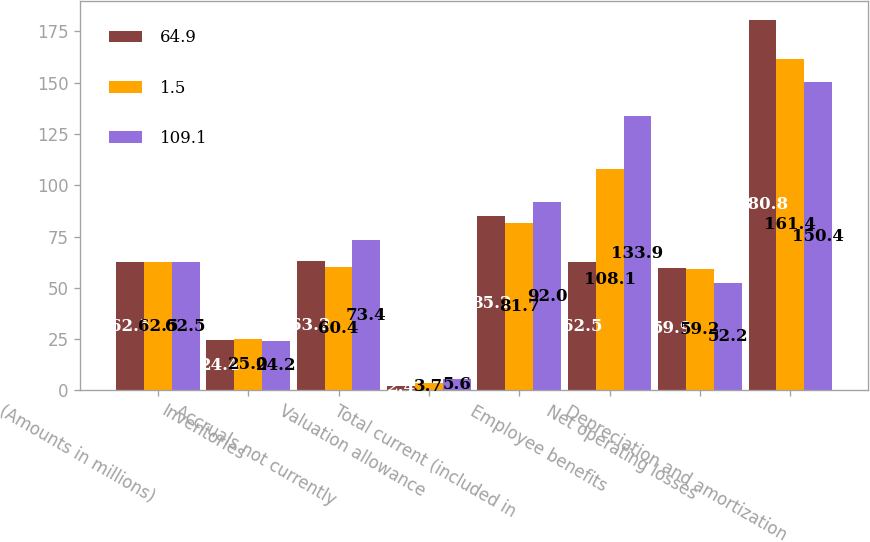Convert chart. <chart><loc_0><loc_0><loc_500><loc_500><stacked_bar_chart><ecel><fcel>(Amounts in millions)<fcel>Inventories<fcel>Accruals not currently<fcel>Valuation allowance<fcel>Total current (included in<fcel>Employee benefits<fcel>Net operating losses<fcel>Depreciation and amortization<nl><fcel>64.9<fcel>62.5<fcel>24.4<fcel>63.2<fcel>2.4<fcel>85.2<fcel>62.5<fcel>59.9<fcel>180.8<nl><fcel>1.5<fcel>62.5<fcel>25<fcel>60.4<fcel>3.7<fcel>81.7<fcel>108.1<fcel>59.2<fcel>161.4<nl><fcel>109.1<fcel>62.5<fcel>24.2<fcel>73.4<fcel>5.6<fcel>92<fcel>133.9<fcel>52.2<fcel>150.4<nl></chart> 